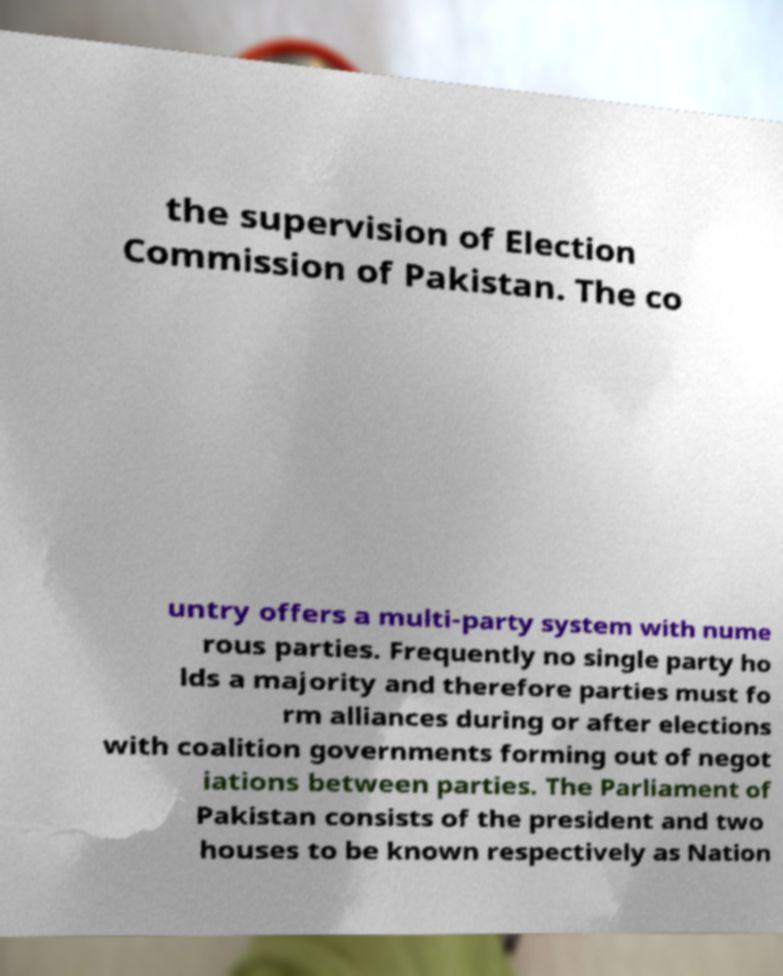What messages or text are displayed in this image? I need them in a readable, typed format. the supervision of Election Commission of Pakistan. The co untry offers a multi-party system with nume rous parties. Frequently no single party ho lds a majority and therefore parties must fo rm alliances during or after elections with coalition governments forming out of negot iations between parties. The Parliament of Pakistan consists of the president and two houses to be known respectively as Nation 